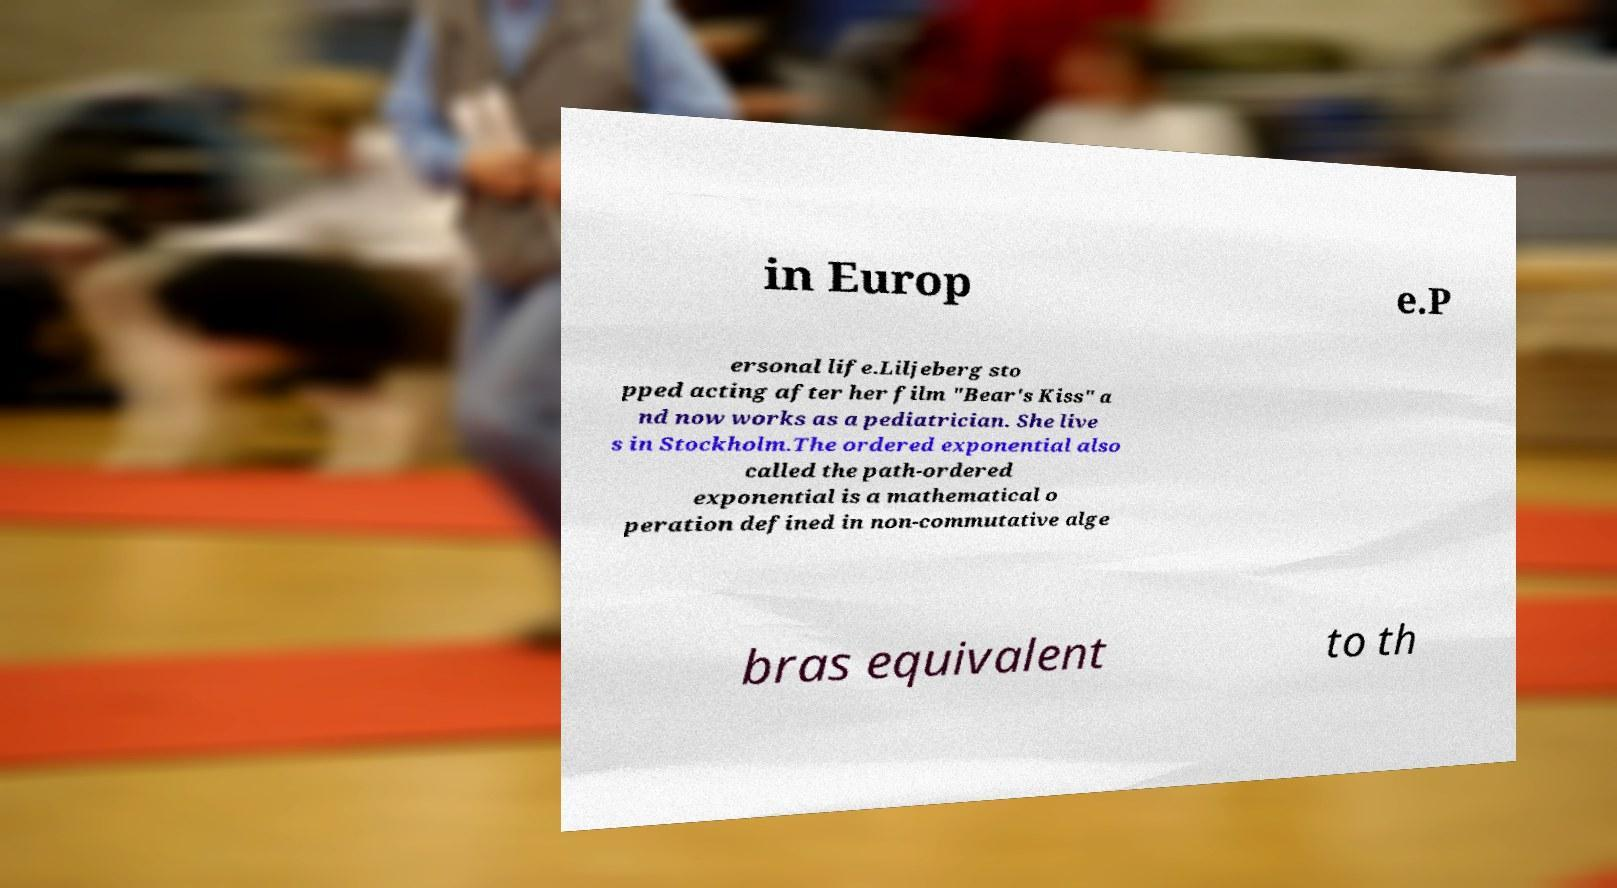Can you read and provide the text displayed in the image?This photo seems to have some interesting text. Can you extract and type it out for me? in Europ e.P ersonal life.Liljeberg sto pped acting after her film "Bear's Kiss" a nd now works as a pediatrician. She live s in Stockholm.The ordered exponential also called the path-ordered exponential is a mathematical o peration defined in non-commutative alge bras equivalent to th 